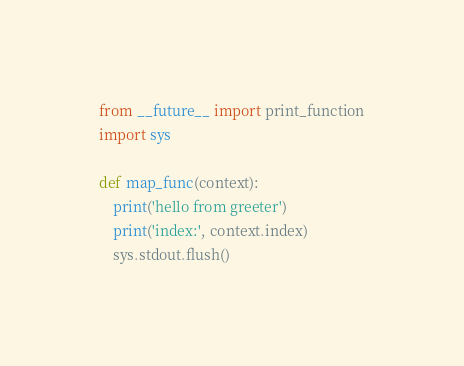<code> <loc_0><loc_0><loc_500><loc_500><_Python_>from __future__ import print_function
import sys

def map_func(context):
    print('hello from greeter')
    print('index:', context.index)
    sys.stdout.flush()</code> 